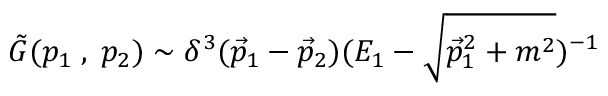Convert formula to latex. <formula><loc_0><loc_0><loc_500><loc_500>\tilde { G } ( p _ { 1 } \, , \, p _ { 2 } ) \sim \delta ^ { 3 } ( \vec { p } _ { 1 } - \vec { p } _ { 2 } ) ( E _ { 1 } - \sqrt { \vec { p } _ { 1 } ^ { 2 } + m ^ { 2 } } ) ^ { - 1 }</formula> 